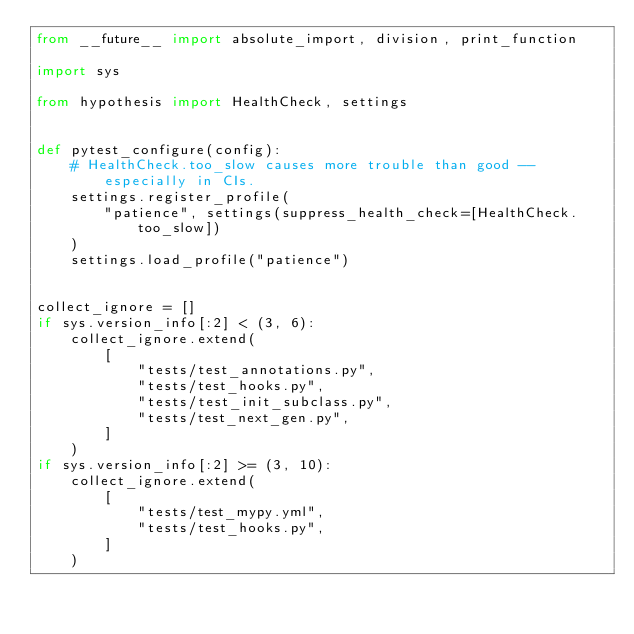<code> <loc_0><loc_0><loc_500><loc_500><_Python_>from __future__ import absolute_import, division, print_function

import sys

from hypothesis import HealthCheck, settings


def pytest_configure(config):
    # HealthCheck.too_slow causes more trouble than good -- especially in CIs.
    settings.register_profile(
        "patience", settings(suppress_health_check=[HealthCheck.too_slow])
    )
    settings.load_profile("patience")


collect_ignore = []
if sys.version_info[:2] < (3, 6):
    collect_ignore.extend(
        [
            "tests/test_annotations.py",
            "tests/test_hooks.py",
            "tests/test_init_subclass.py",
            "tests/test_next_gen.py",
        ]
    )
if sys.version_info[:2] >= (3, 10):
    collect_ignore.extend(
        [
            "tests/test_mypy.yml",
            "tests/test_hooks.py",
        ]
    )
</code> 